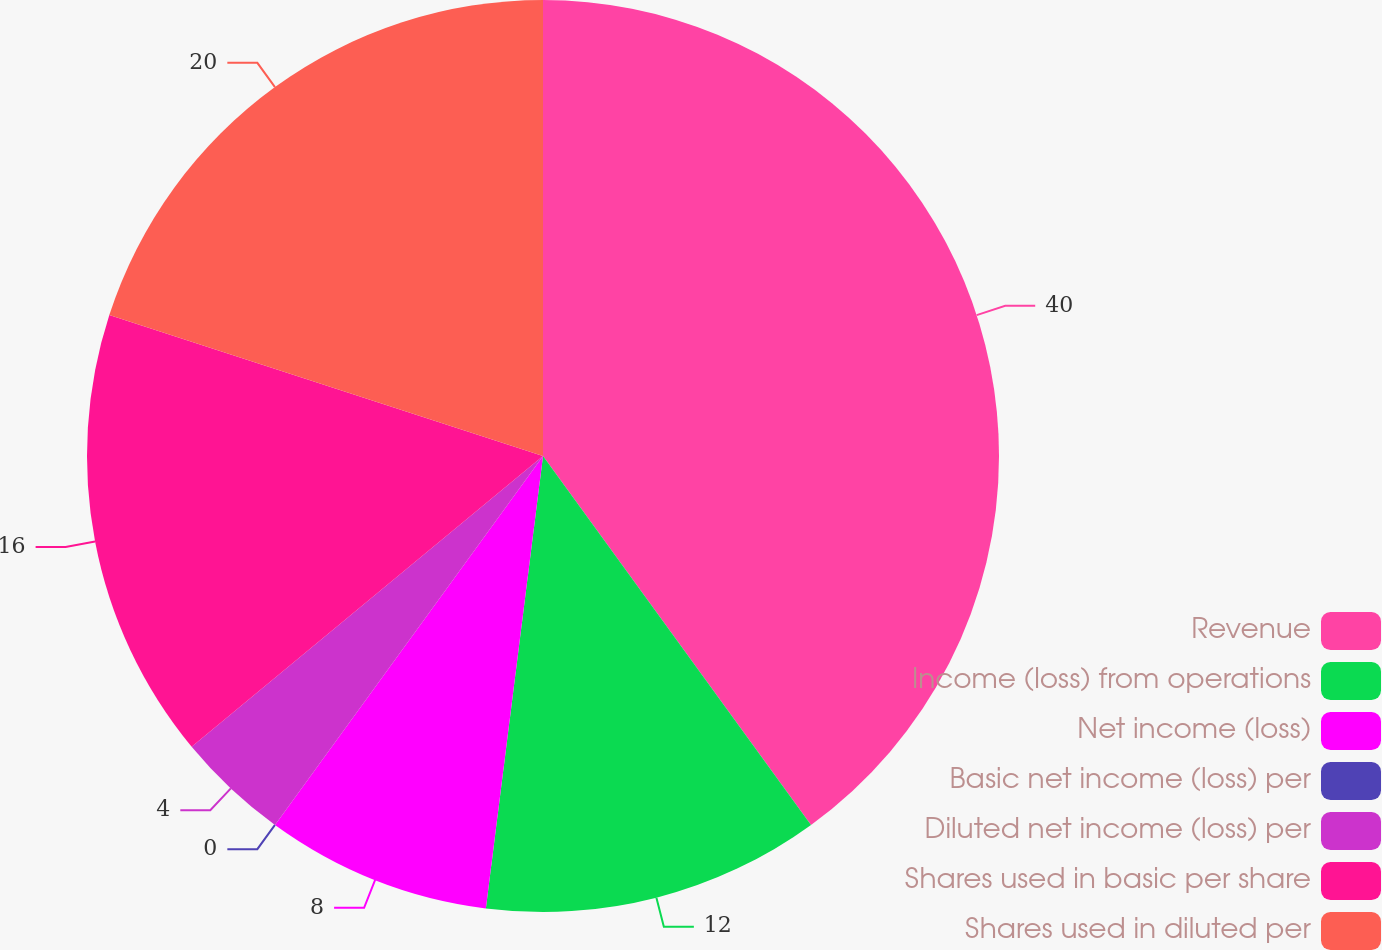Convert chart. <chart><loc_0><loc_0><loc_500><loc_500><pie_chart><fcel>Revenue<fcel>Income (loss) from operations<fcel>Net income (loss)<fcel>Basic net income (loss) per<fcel>Diluted net income (loss) per<fcel>Shares used in basic per share<fcel>Shares used in diluted per<nl><fcel>40.0%<fcel>12.0%<fcel>8.0%<fcel>0.0%<fcel>4.0%<fcel>16.0%<fcel>20.0%<nl></chart> 